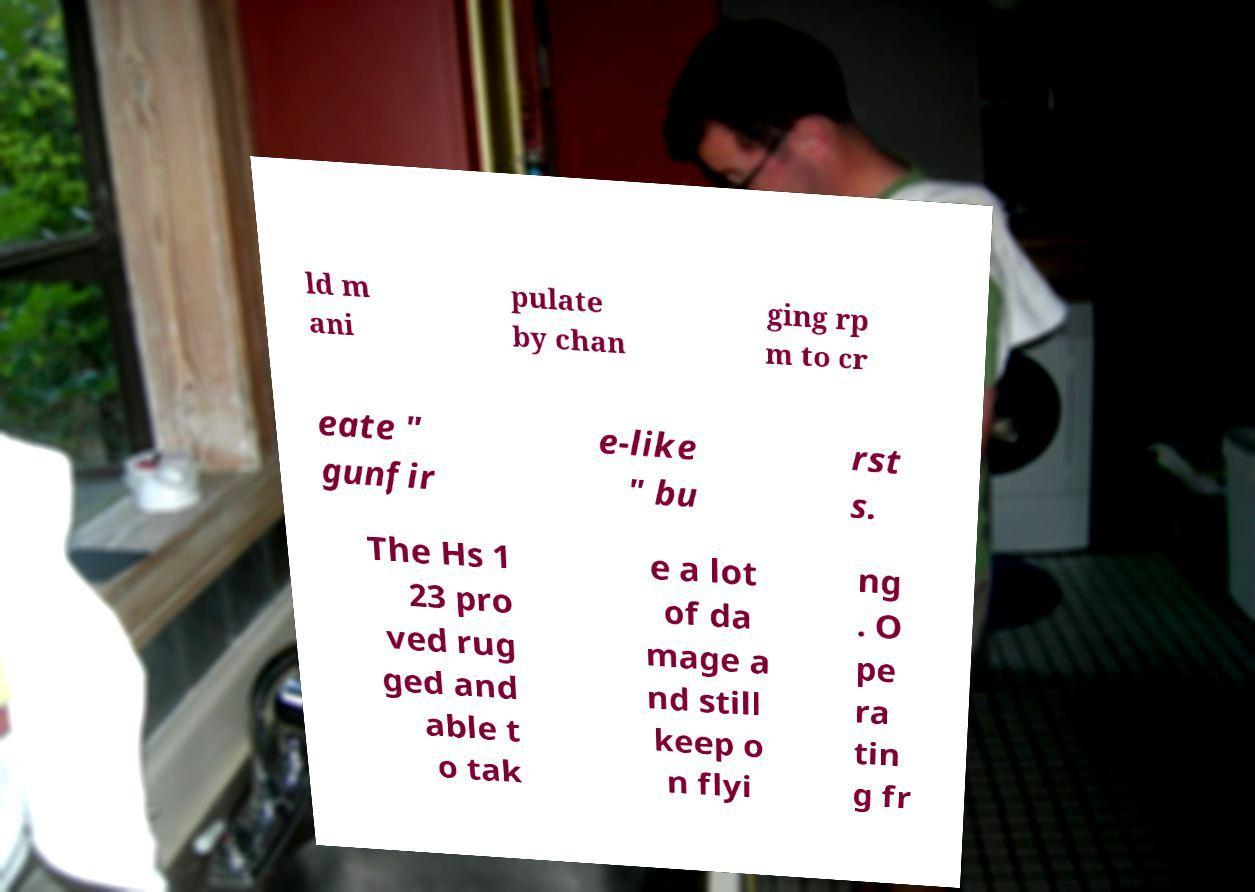What messages or text are displayed in this image? I need them in a readable, typed format. ld m ani pulate by chan ging rp m to cr eate " gunfir e-like " bu rst s. The Hs 1 23 pro ved rug ged and able t o tak e a lot of da mage a nd still keep o n flyi ng . O pe ra tin g fr 